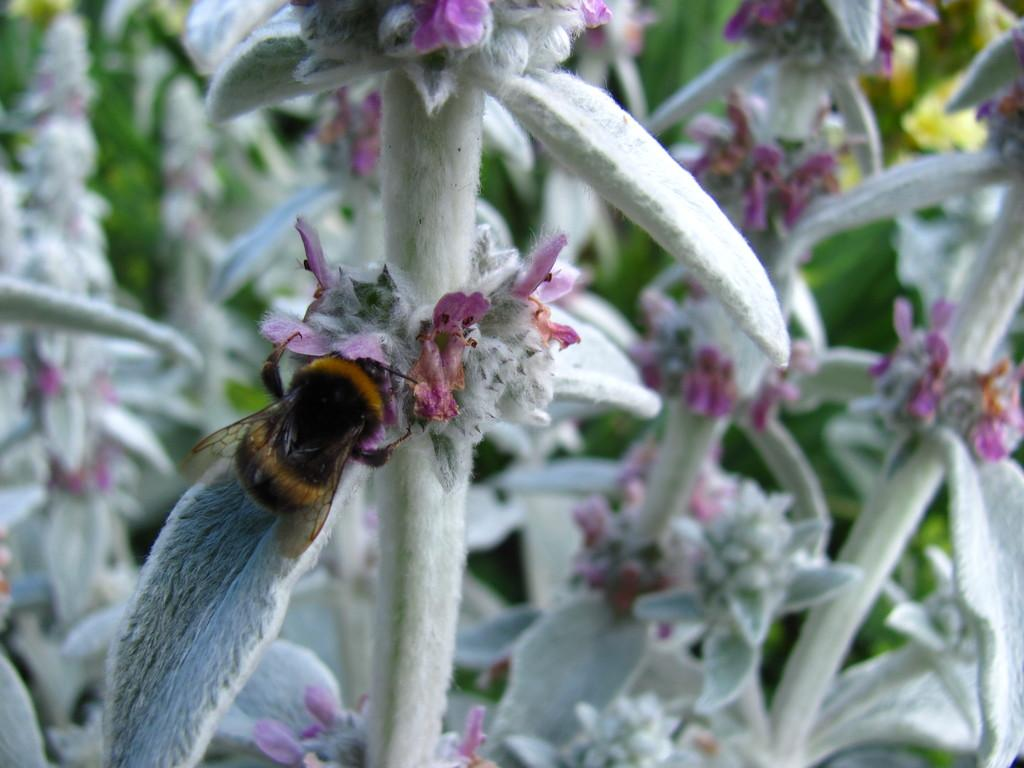What is present in the image that is small and has wings? There is a fly in the image. Where is the fly located in the image? The fly is on the plants. What other living organisms can be seen in the image? There are flowers in the image. What type of powder is being used to style the fly's hair in the image? There is no indication in the image that the fly has hair or that any powder is being used to style it. 